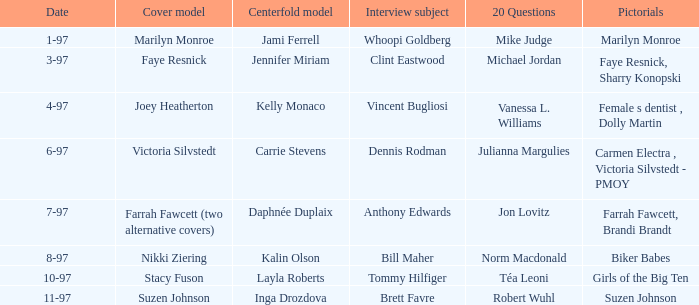Who was the centerfold model when a pictorial was done on marilyn monroe? Jami Ferrell. 